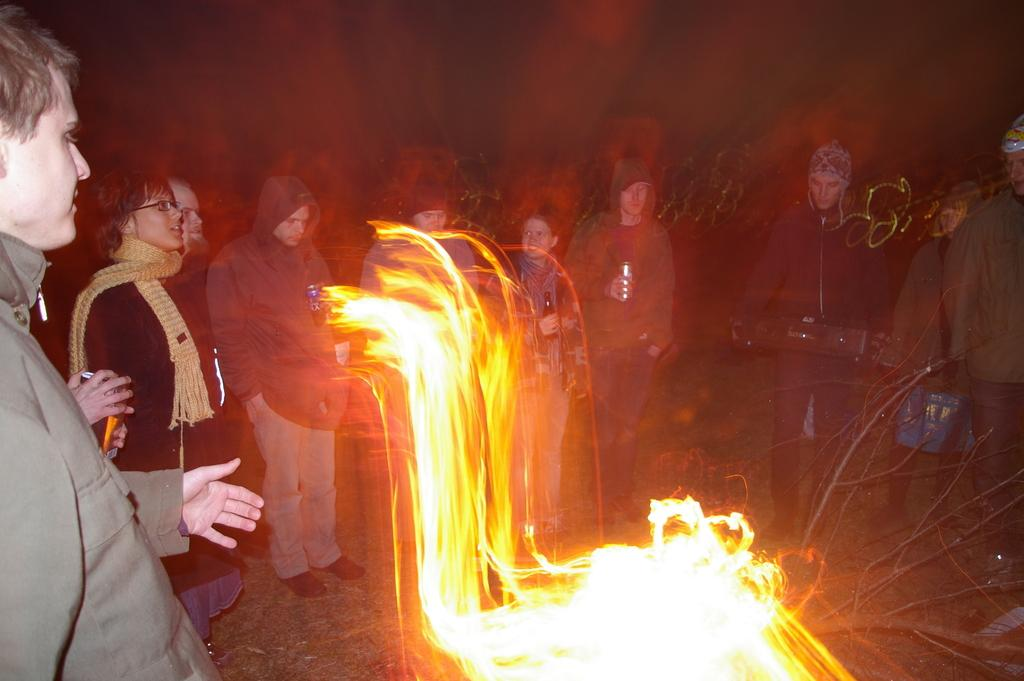What is the main feature in the center of the image? There are flames in the center of the image. Where are the people located in the image? People are standing on the left side and in the center of the image. What can be observed about the background of the image? The background of the image is dark. What type of question is being asked on the stage in the image? There is no stage present in the image, and therefore no questions are being asked on a stage. 